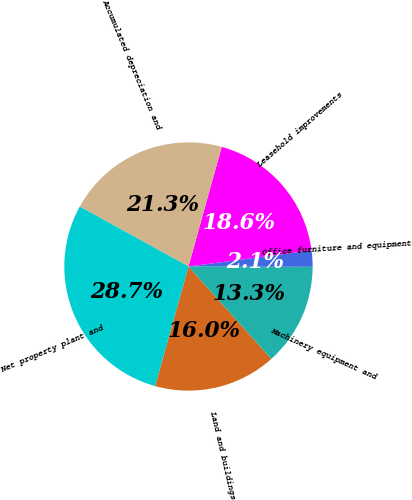Convert chart. <chart><loc_0><loc_0><loc_500><loc_500><pie_chart><fcel>Land and buildings<fcel>Machinery equipment and<fcel>Office furniture and equipment<fcel>Leasehold improvements<fcel>Accumulated depreciation and<fcel>Net property plant and<nl><fcel>15.98%<fcel>13.32%<fcel>2.1%<fcel>18.63%<fcel>21.29%<fcel>28.68%<nl></chart> 